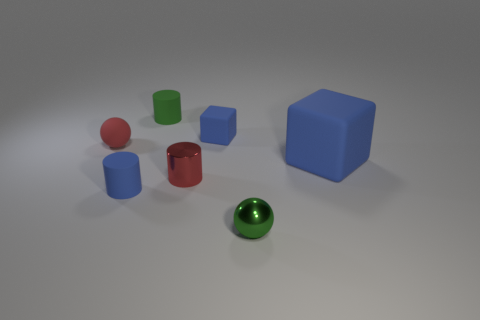What material is the blue object that is in front of the tiny red object that is to the right of the small blue matte cylinder?
Provide a short and direct response. Rubber. Are there an equal number of red metallic things that are behind the big blue block and balls that are on the left side of the green ball?
Provide a succinct answer. No. Is the red matte thing the same shape as the green rubber object?
Your response must be concise. No. There is a object that is left of the tiny red metal cylinder and in front of the red metal cylinder; what material is it?
Offer a terse response. Rubber. How many other blue things are the same shape as the big blue object?
Provide a short and direct response. 1. There is a matte cube that is left of the block to the right of the blue thing behind the rubber ball; how big is it?
Your answer should be very brief. Small. Is the number of large things that are behind the tiny blue cube greater than the number of blue metallic cylinders?
Give a very brief answer. No. Is there a blue rubber cube?
Your answer should be very brief. Yes. What number of blue matte cylinders have the same size as the red cylinder?
Provide a short and direct response. 1. Is the number of large blue rubber things that are in front of the small red cylinder greater than the number of shiny things that are in front of the small metal sphere?
Offer a very short reply. No. 